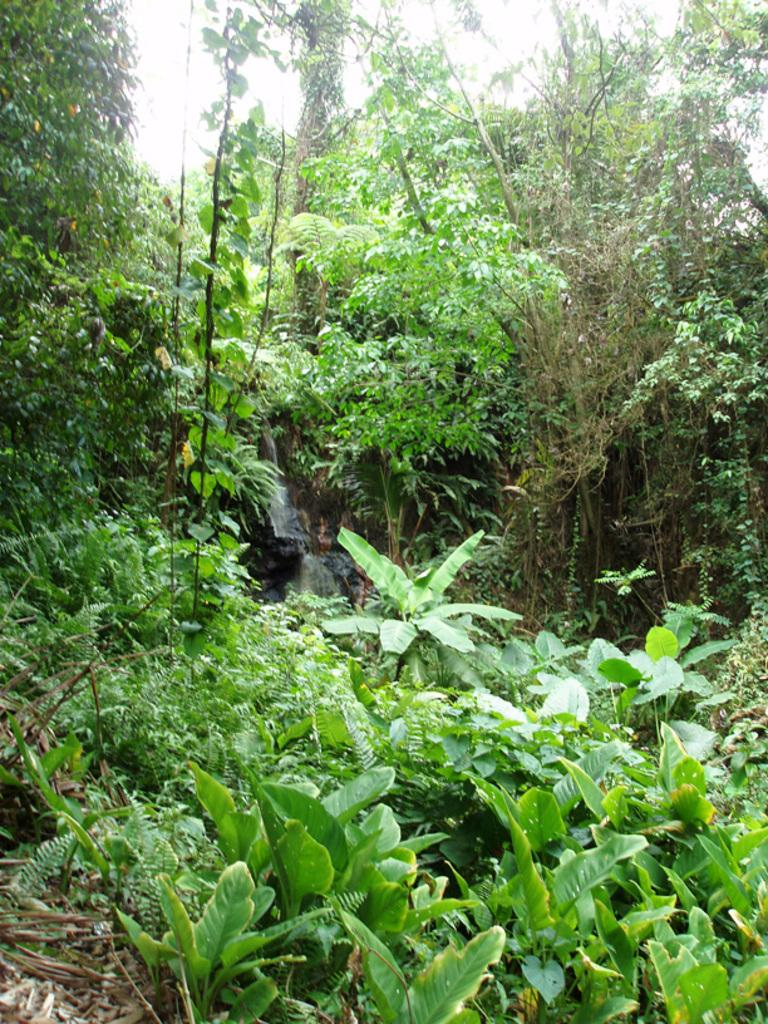What type of vegetation can be seen in the image? There is a group of trees and plants in the image. What might be the condition of the leaves on the trees? Dried leaves are present in the image, suggesting that some leaves have fallen or are in the process of falling. What can be seen in the background of the image? The sky is visible in the image. What type of plastic object can be seen in the image? There is no plastic object present in the image. What emotion is being expressed by the trees in the image? Trees do not express emotions, so this question cannot be answered definitively based on the facts provided. 